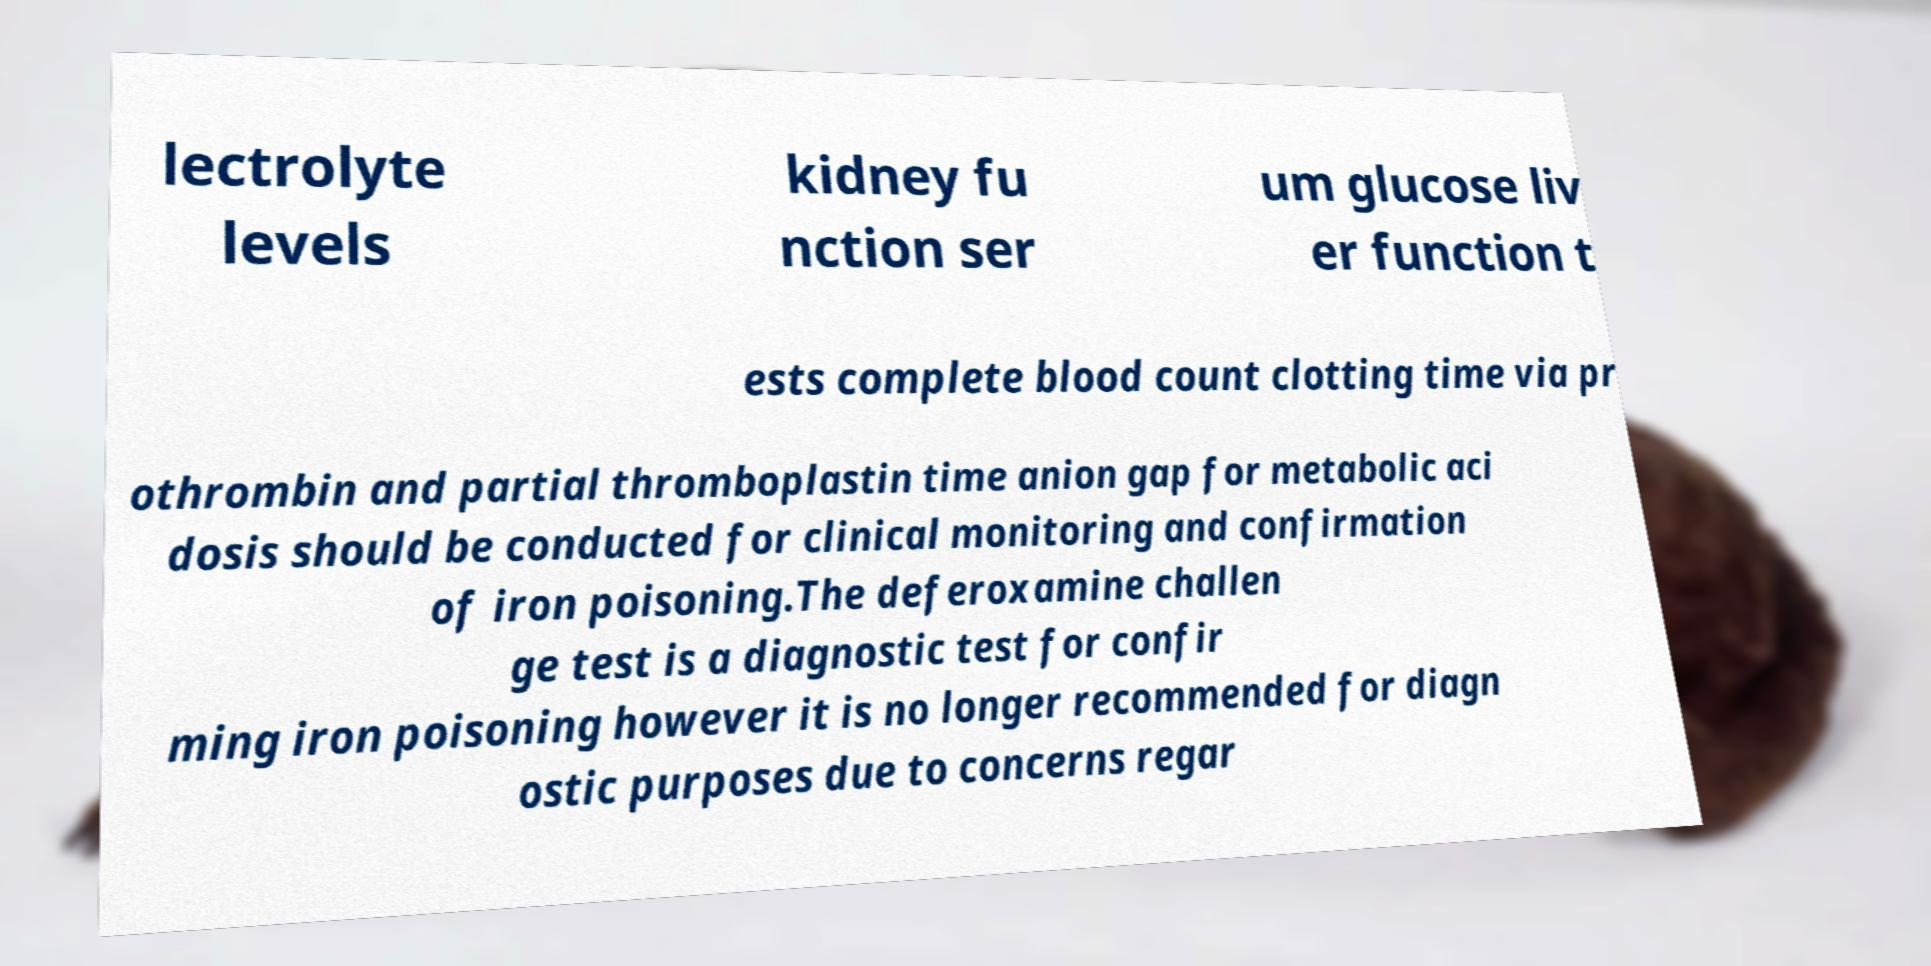For documentation purposes, I need the text within this image transcribed. Could you provide that? lectrolyte levels kidney fu nction ser um glucose liv er function t ests complete blood count clotting time via pr othrombin and partial thromboplastin time anion gap for metabolic aci dosis should be conducted for clinical monitoring and confirmation of iron poisoning.The deferoxamine challen ge test is a diagnostic test for confir ming iron poisoning however it is no longer recommended for diagn ostic purposes due to concerns regar 